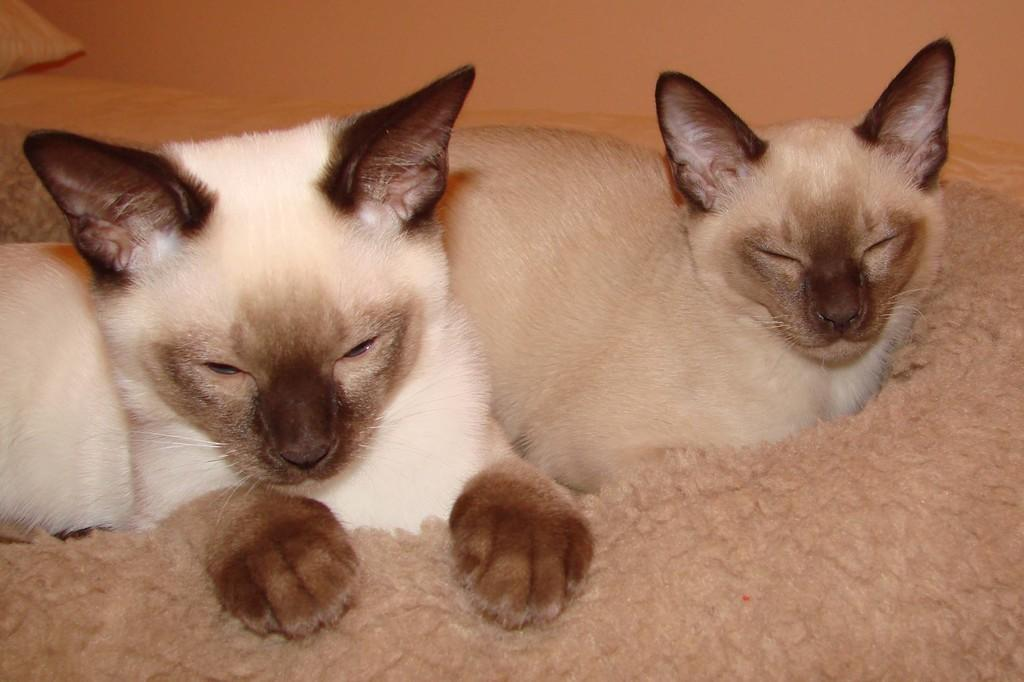What type of animals are on the bed in the image? There are cats on the bed in the image. What type of soft furnishing can be seen in the image? There is a pillow in the image. What type of fabric is present in the image? There is a cloth in the image. What type of architectural feature is visible in the image? There is a wall visible in the image. Can you see any passengers waiting at the seashore in the image? There is no reference to passengers or a seashore in the image; it features cats on a bed with a pillow, cloth, and wall. 